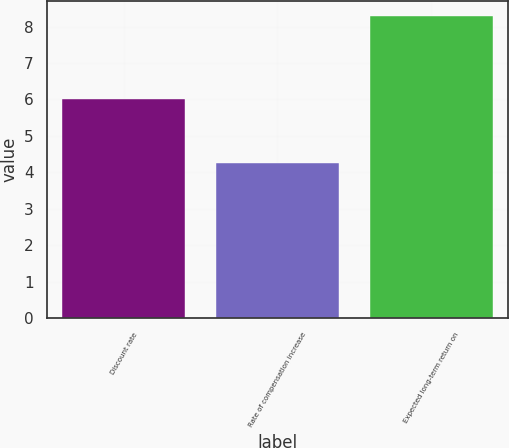<chart> <loc_0><loc_0><loc_500><loc_500><bar_chart><fcel>Discount rate<fcel>Rate of compensation increase<fcel>Expected long-term return on<nl><fcel>6<fcel>4.25<fcel>8.3<nl></chart> 